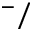Convert formula to latex. <formula><loc_0><loc_0><loc_500><loc_500>^ { - } /</formula> 